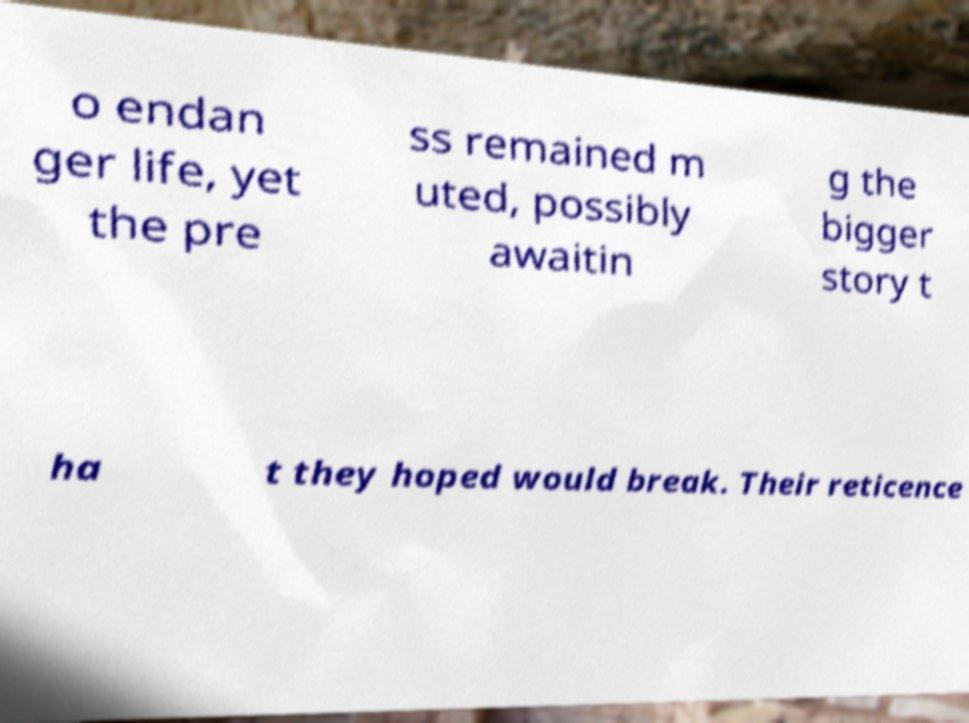What messages or text are displayed in this image? I need them in a readable, typed format. o endan ger life, yet the pre ss remained m uted, possibly awaitin g the bigger story t ha t they hoped would break. Their reticence 